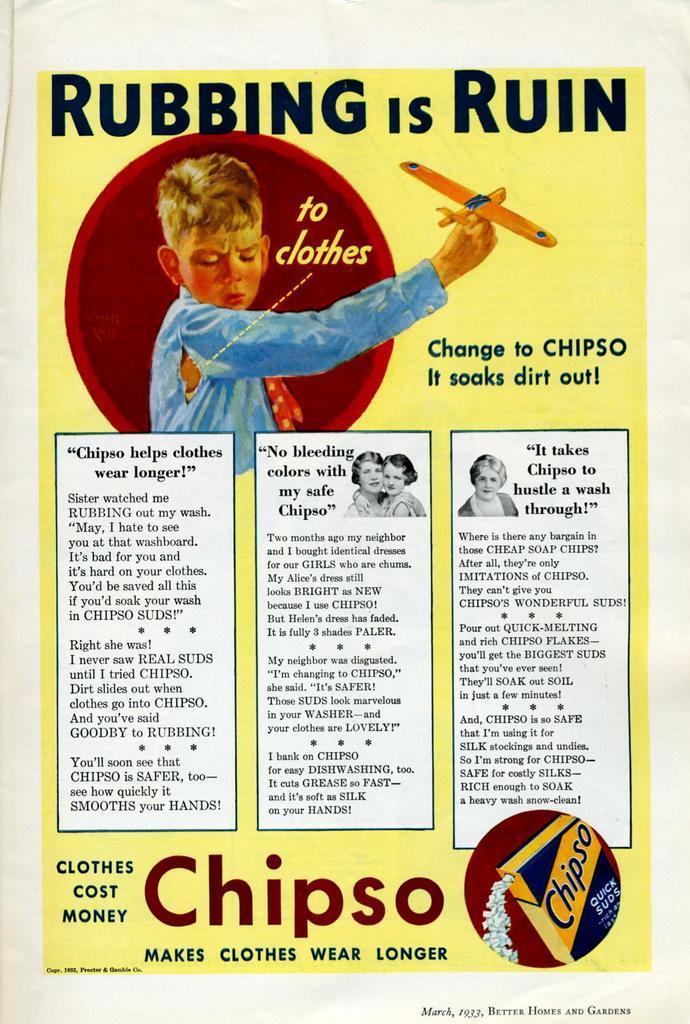Could you give a brief overview of what you see in this image? In this image we can see poster in which there is some text and a person wearing blue color dress holding an aircraft in his hands. 